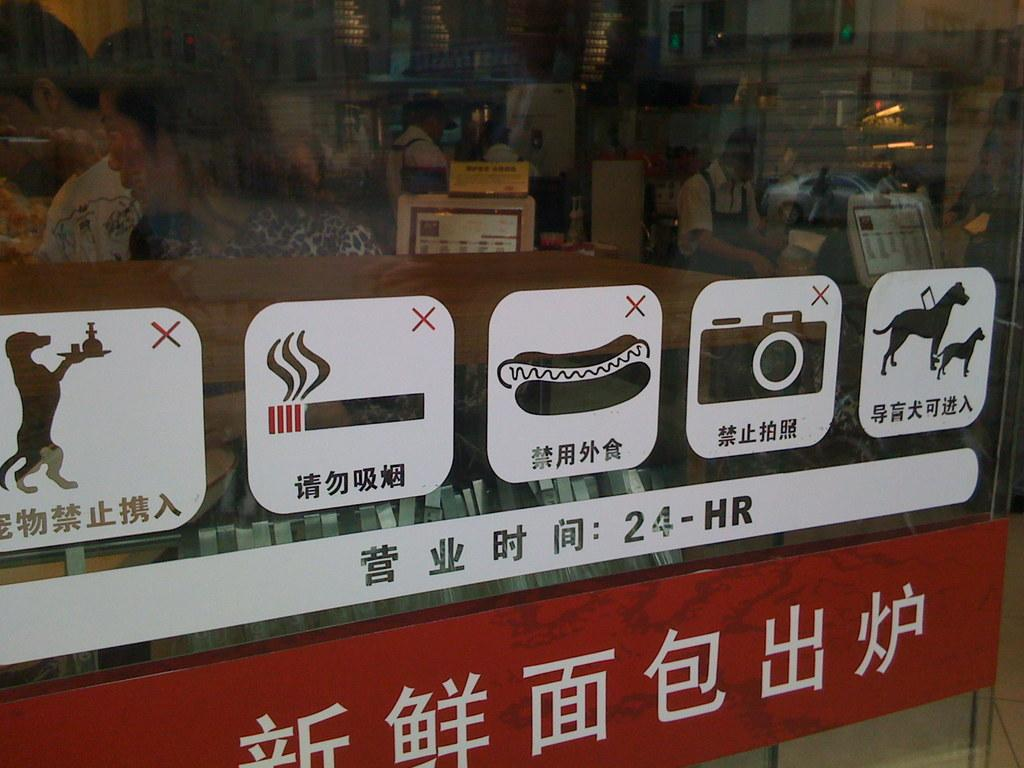What is on the glass in the image? There are stickers on the glass. What can be seen through the glass? People and screens are visible through the glass. What reflections are present on the glass? There is a reflection of a car and a reflection of a person on the glass. What type of trousers is the person wearing in the reflection on the glass? There is no information about the person's trousers in the image, as the focus is on the stickers, people, screens, and reflections. 